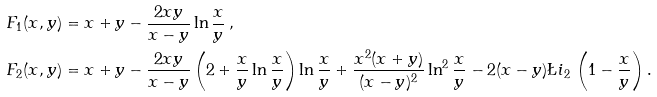<formula> <loc_0><loc_0><loc_500><loc_500>F _ { 1 } ( x , y ) & = x + y - \frac { 2 x y } { x - y } \ln \frac { x } { y } \, , \\ F _ { 2 } ( x , y ) & = x + y - \frac { 2 x y } { x - y } \left ( 2 + \frac { x } { y } \ln \frac { x } { y } \right ) \ln \frac { x } { y } + \frac { x ^ { 2 } ( x + y ) } { ( x - y ) ^ { 2 } } \ln ^ { 2 } \frac { x } { y } - 2 ( x - y ) \L i _ { 2 } \, \left ( 1 - \frac { x } { y } \right ) .</formula> 